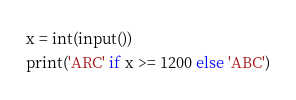Convert code to text. <code><loc_0><loc_0><loc_500><loc_500><_Python_>x = int(input())
print('ARC' if x >= 1200 else 'ABC')</code> 